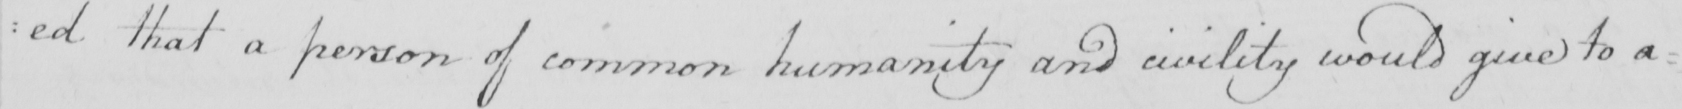What does this handwritten line say? : ed that a person of common humanity and civility would give to a : 